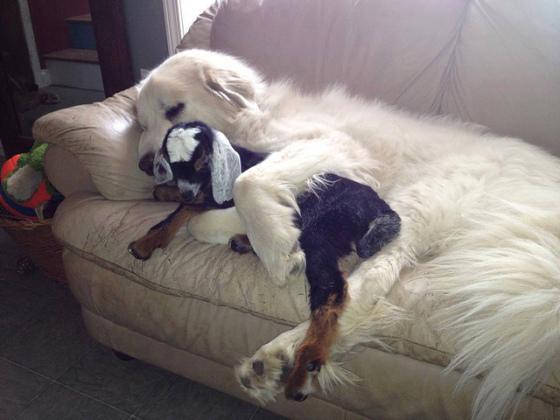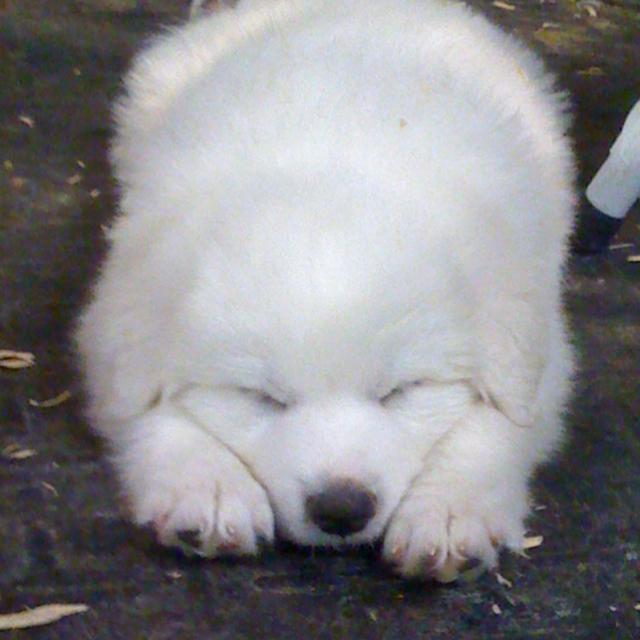The first image is the image on the left, the second image is the image on the right. Examine the images to the left and right. Is the description "One of the pictures shows a puppy sleeping alone." accurate? Answer yes or no. Yes. 